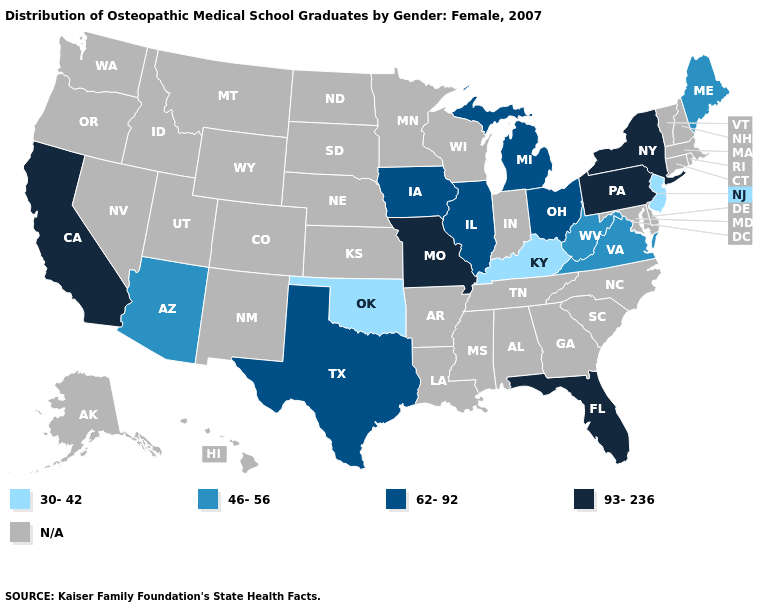Name the states that have a value in the range 62-92?
Answer briefly. Illinois, Iowa, Michigan, Ohio, Texas. Does the map have missing data?
Keep it brief. Yes. Among the states that border North Carolina , which have the highest value?
Short answer required. Virginia. What is the highest value in the USA?
Be succinct. 93-236. What is the value of Hawaii?
Concise answer only. N/A. Among the states that border Connecticut , which have the highest value?
Quick response, please. New York. Does the map have missing data?
Concise answer only. Yes. What is the value of Utah?
Write a very short answer. N/A. Does the map have missing data?
Short answer required. Yes. Name the states that have a value in the range 93-236?
Concise answer only. California, Florida, Missouri, New York, Pennsylvania. What is the value of South Carolina?
Be succinct. N/A. Does New Jersey have the lowest value in the USA?
Keep it brief. Yes. What is the value of North Dakota?
Quick response, please. N/A. Name the states that have a value in the range 46-56?
Keep it brief. Arizona, Maine, Virginia, West Virginia. Which states have the lowest value in the USA?
Short answer required. Kentucky, New Jersey, Oklahoma. 